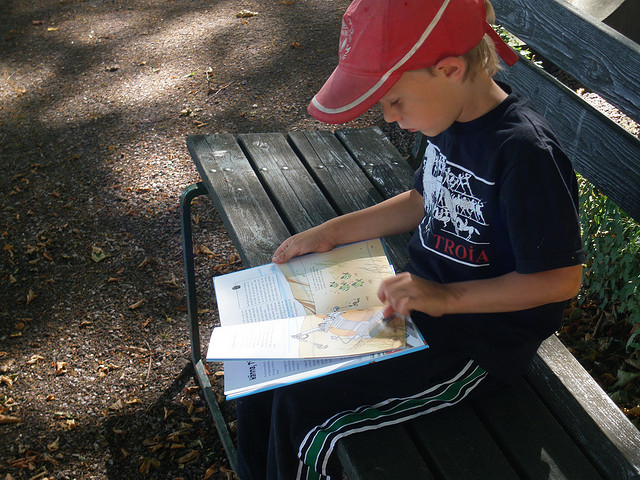Please extract the text content from this image. TROIA 